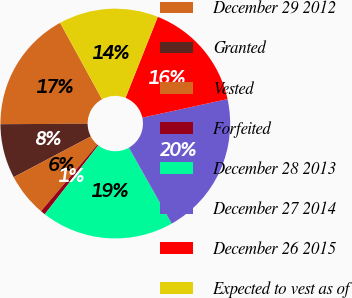<chart> <loc_0><loc_0><loc_500><loc_500><pie_chart><fcel>December 29 2012<fcel>Granted<fcel>Vested<fcel>Forfeited<fcel>December 28 2013<fcel>December 27 2014<fcel>December 26 2015<fcel>Expected to vest as of<nl><fcel>17.12%<fcel>7.64%<fcel>6.08%<fcel>0.67%<fcel>18.69%<fcel>20.25%<fcel>15.56%<fcel>14.0%<nl></chart> 